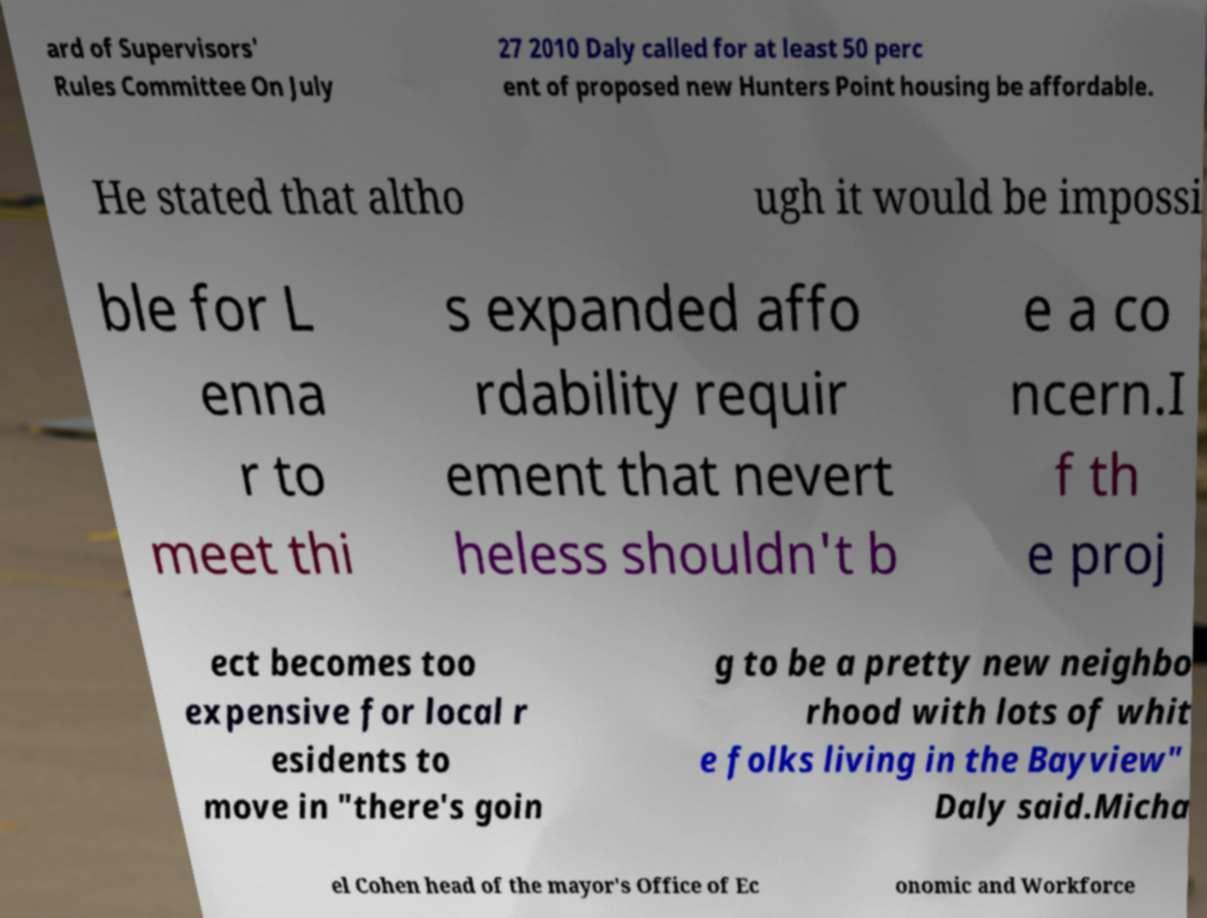For documentation purposes, I need the text within this image transcribed. Could you provide that? ard of Supervisors' Rules Committee On July 27 2010 Daly called for at least 50 perc ent of proposed new Hunters Point housing be affordable. He stated that altho ugh it would be impossi ble for L enna r to meet thi s expanded affo rdability requir ement that nevert heless shouldn't b e a co ncern.I f th e proj ect becomes too expensive for local r esidents to move in "there's goin g to be a pretty new neighbo rhood with lots of whit e folks living in the Bayview" Daly said.Micha el Cohen head of the mayor's Office of Ec onomic and Workforce 